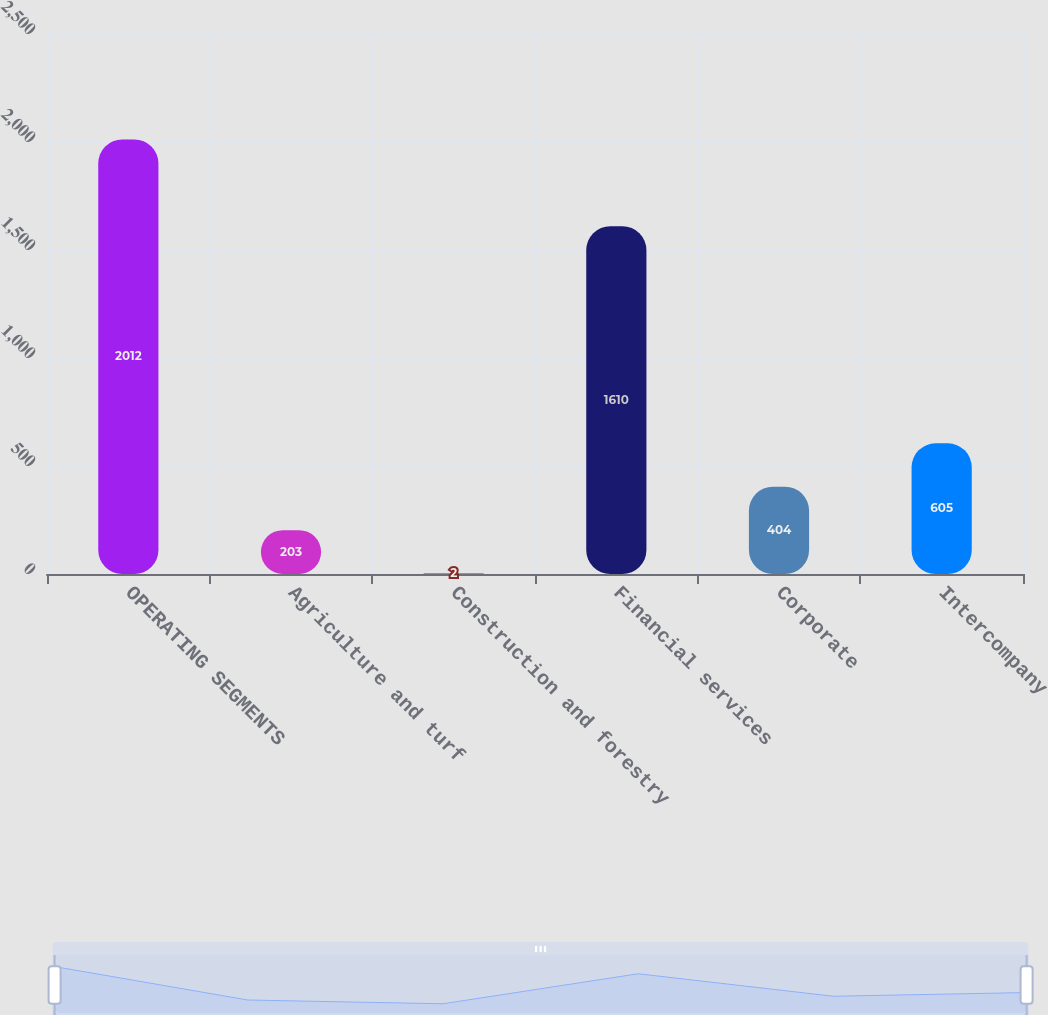Convert chart to OTSL. <chart><loc_0><loc_0><loc_500><loc_500><bar_chart><fcel>OPERATING SEGMENTS<fcel>Agriculture and turf<fcel>Construction and forestry<fcel>Financial services<fcel>Corporate<fcel>Intercompany<nl><fcel>2012<fcel>203<fcel>2<fcel>1610<fcel>404<fcel>605<nl></chart> 